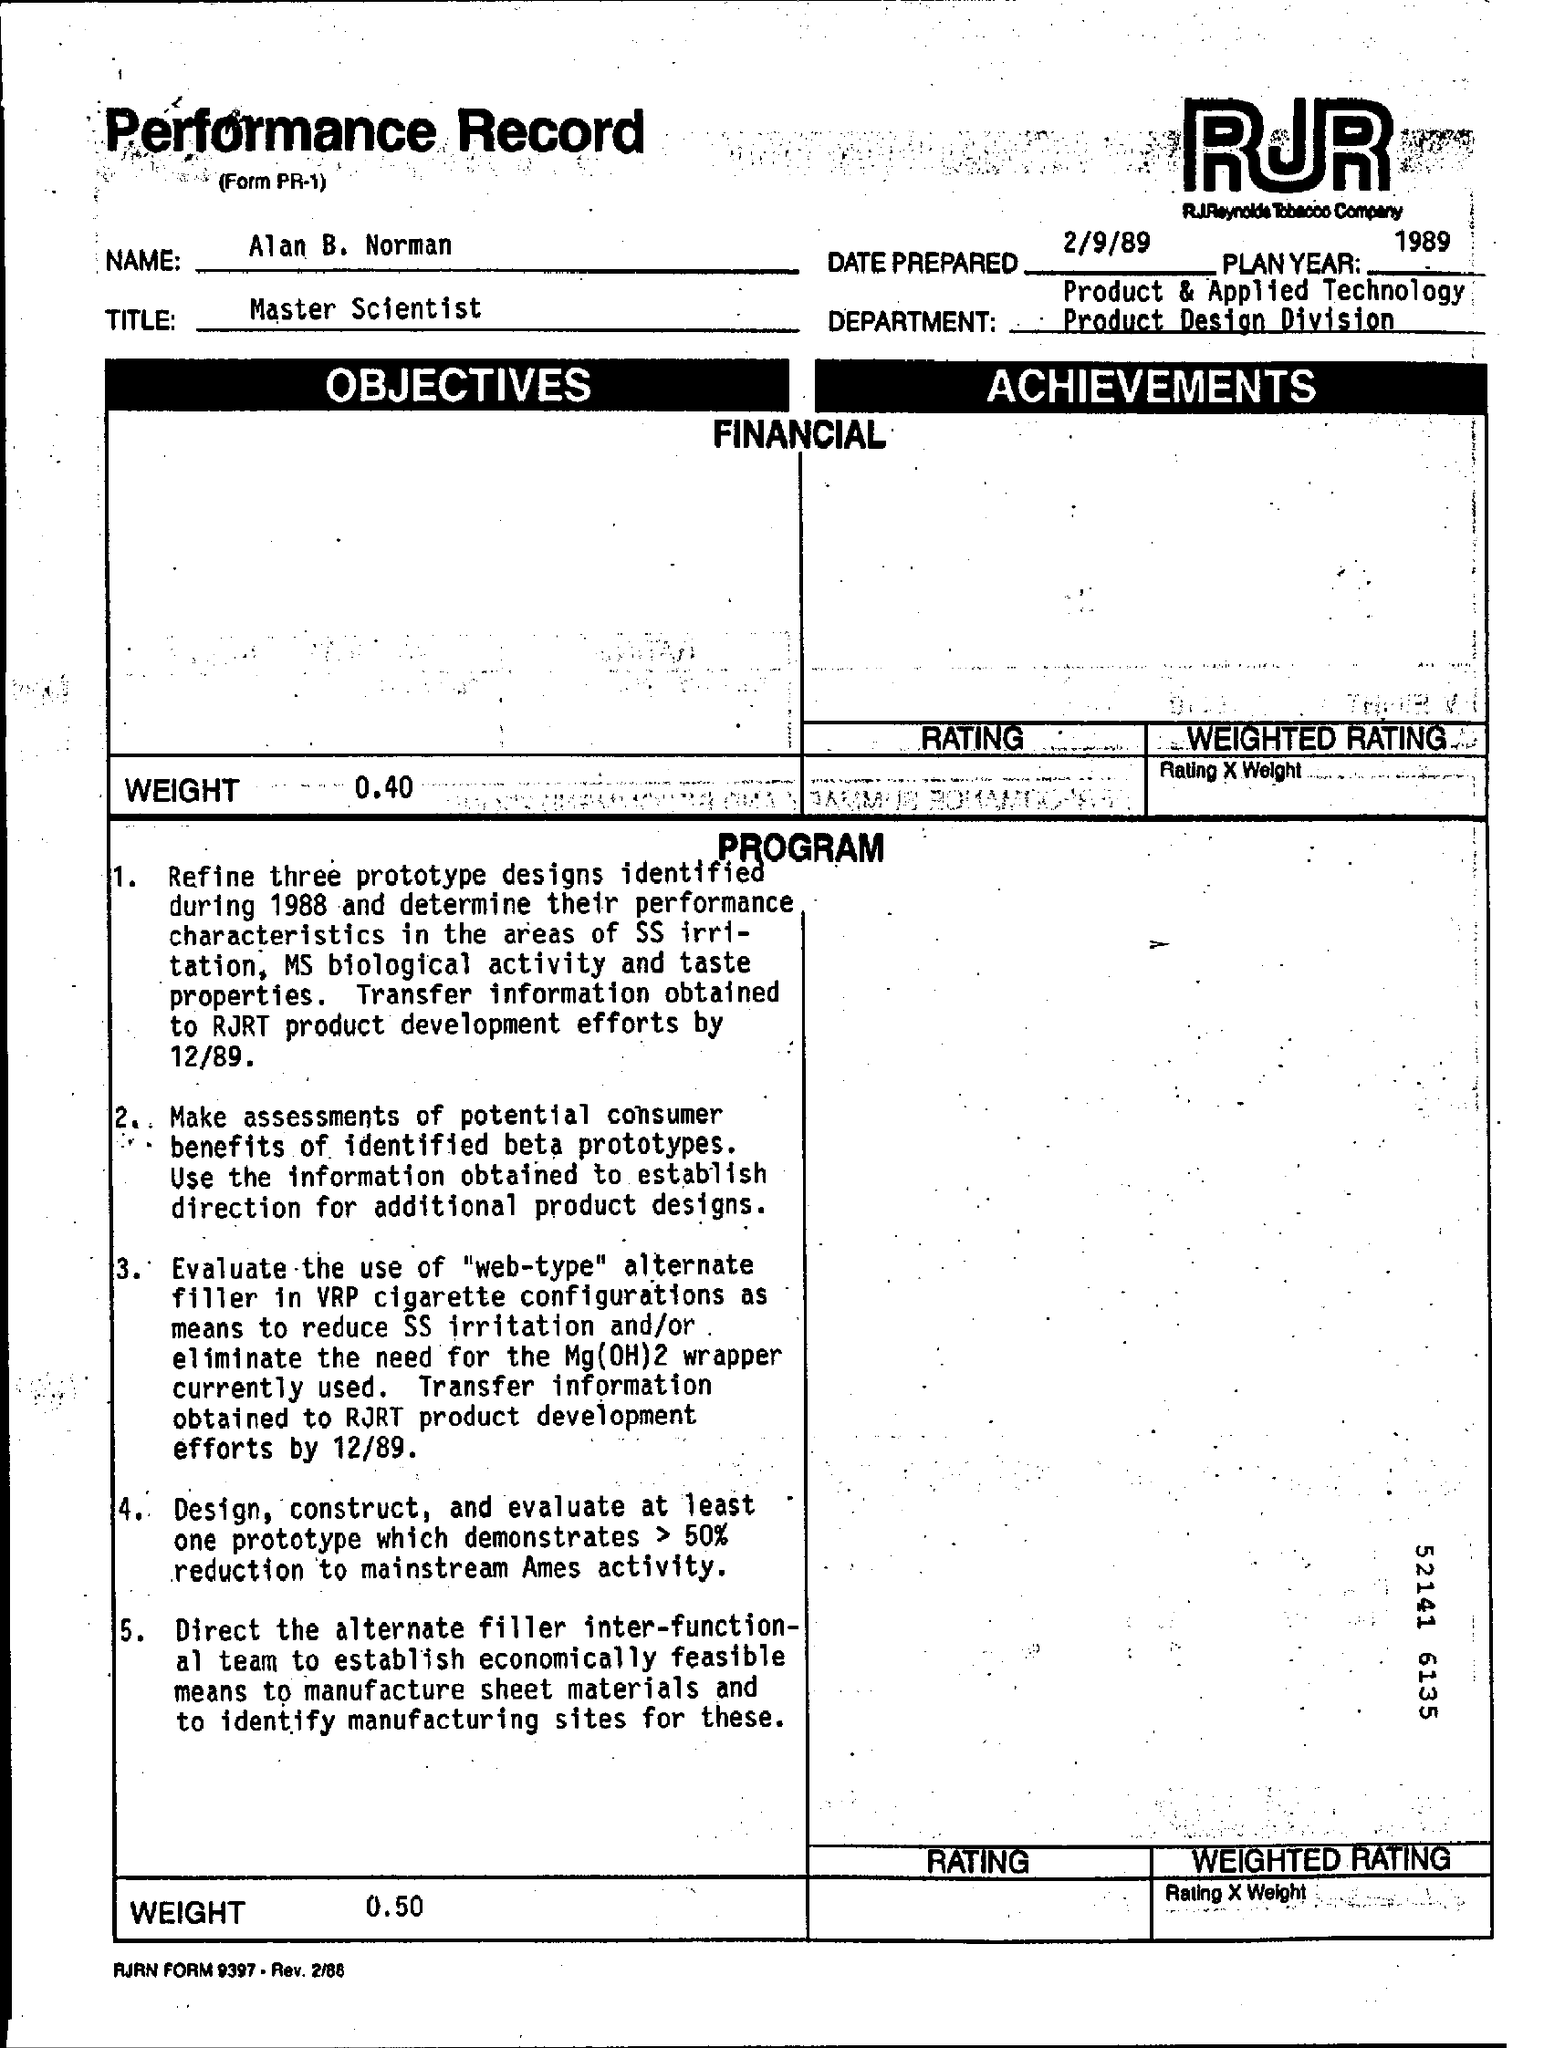Highlight a few significant elements in this photo. The date prepared is February 9th, 1989. Master Scientist" is a title. The weight mentioned in the program is 0.50. The weight mentioned in the objectives is 0.40. The name mentioned is Alan B. Norman. 